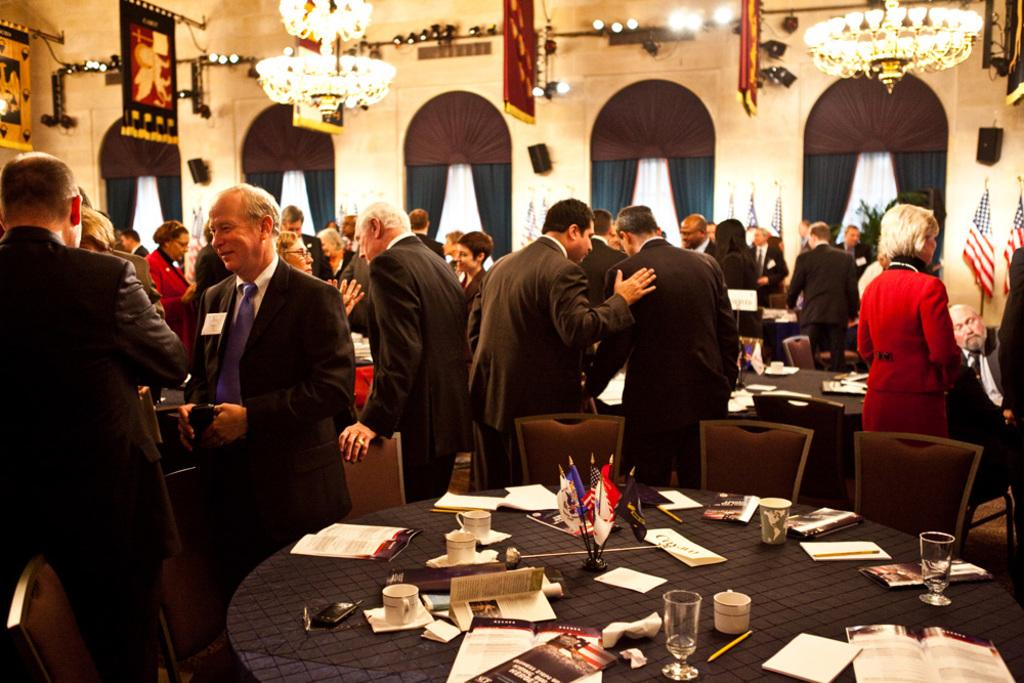How many people are present in the image? There are many people in the image. What type of furniture is visible in the image? There are tables and chairs in the image. What items can be seen on the tables? There are books and coffee cups on the tables in the image. What decorative element is hanging from the ceiling? There is a chandelier on the ceiling in the image. What can be inferred about the setting based on the presence of tables, chairs, and people? The setting appears to be a conference area. Are there any fairies visible in the image? No, there are no fairies present in the image. What type of leg is being used to support the tables in the image? The tables in the image are supported by legs, but the specific type of leg cannot be determined from the image. 